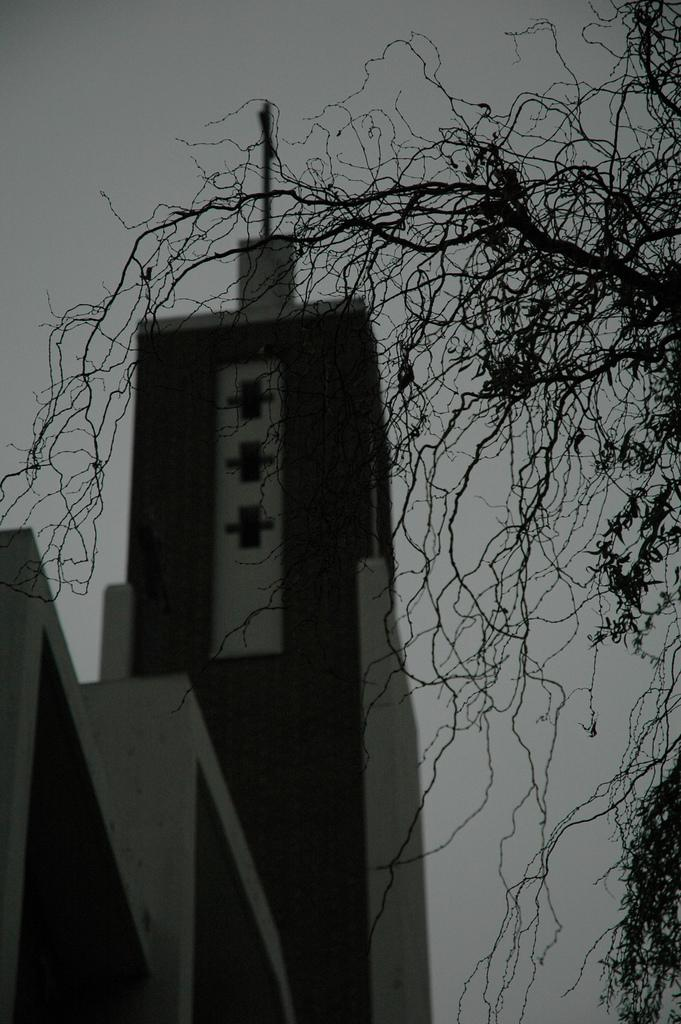What structure can be seen on the left side of the image? There is a pole on a building on the left side of the image. What type of vegetation is on the right side of the image? There are truncated trees on the right side of the image. What is visible in the image besides the pole and trees? The sky is visible in the image. Can you see any ants crawling on the pole in the image? There are no ants visible in the image, and therefore no such activity can be observed. Is there a snake slithering through the truncated trees in the image? There is no snake present in the image; only the pole, building, trees, and sky are visible. 